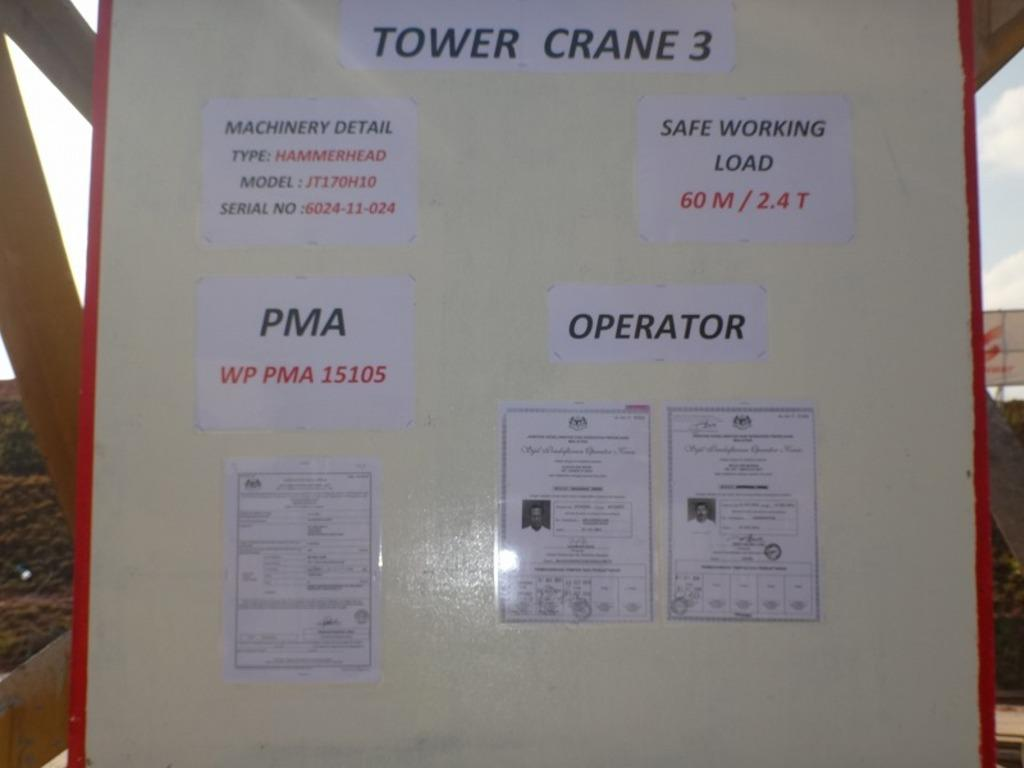Provide a one-sentence caption for the provided image. A sign board with many papers taped to it for a Tower crane. 